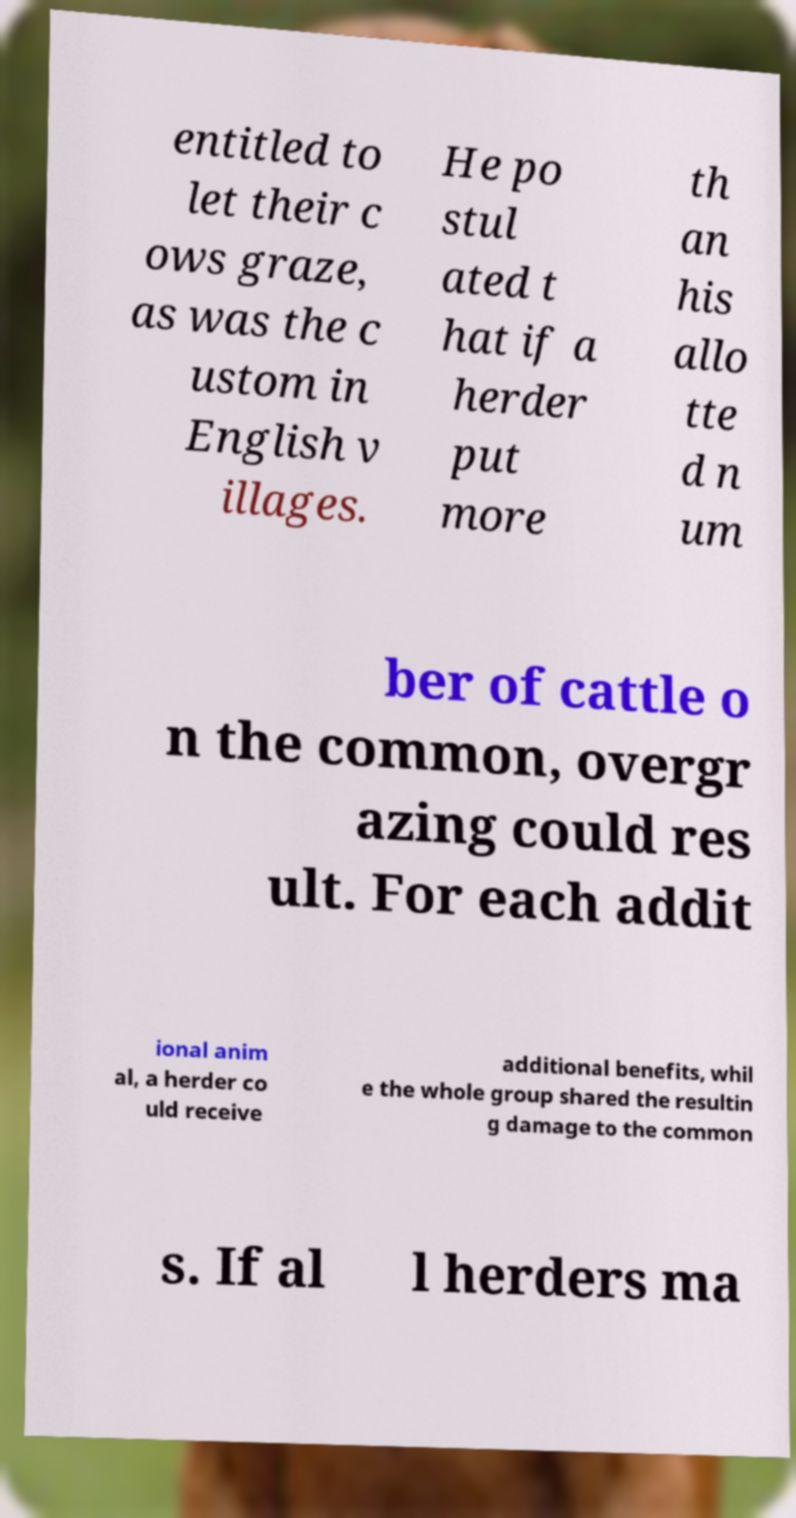Please identify and transcribe the text found in this image. entitled to let their c ows graze, as was the c ustom in English v illages. He po stul ated t hat if a herder put more th an his allo tte d n um ber of cattle o n the common, overgr azing could res ult. For each addit ional anim al, a herder co uld receive additional benefits, whil e the whole group shared the resultin g damage to the common s. If al l herders ma 